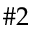<formula> <loc_0><loc_0><loc_500><loc_500>\# 2</formula> 